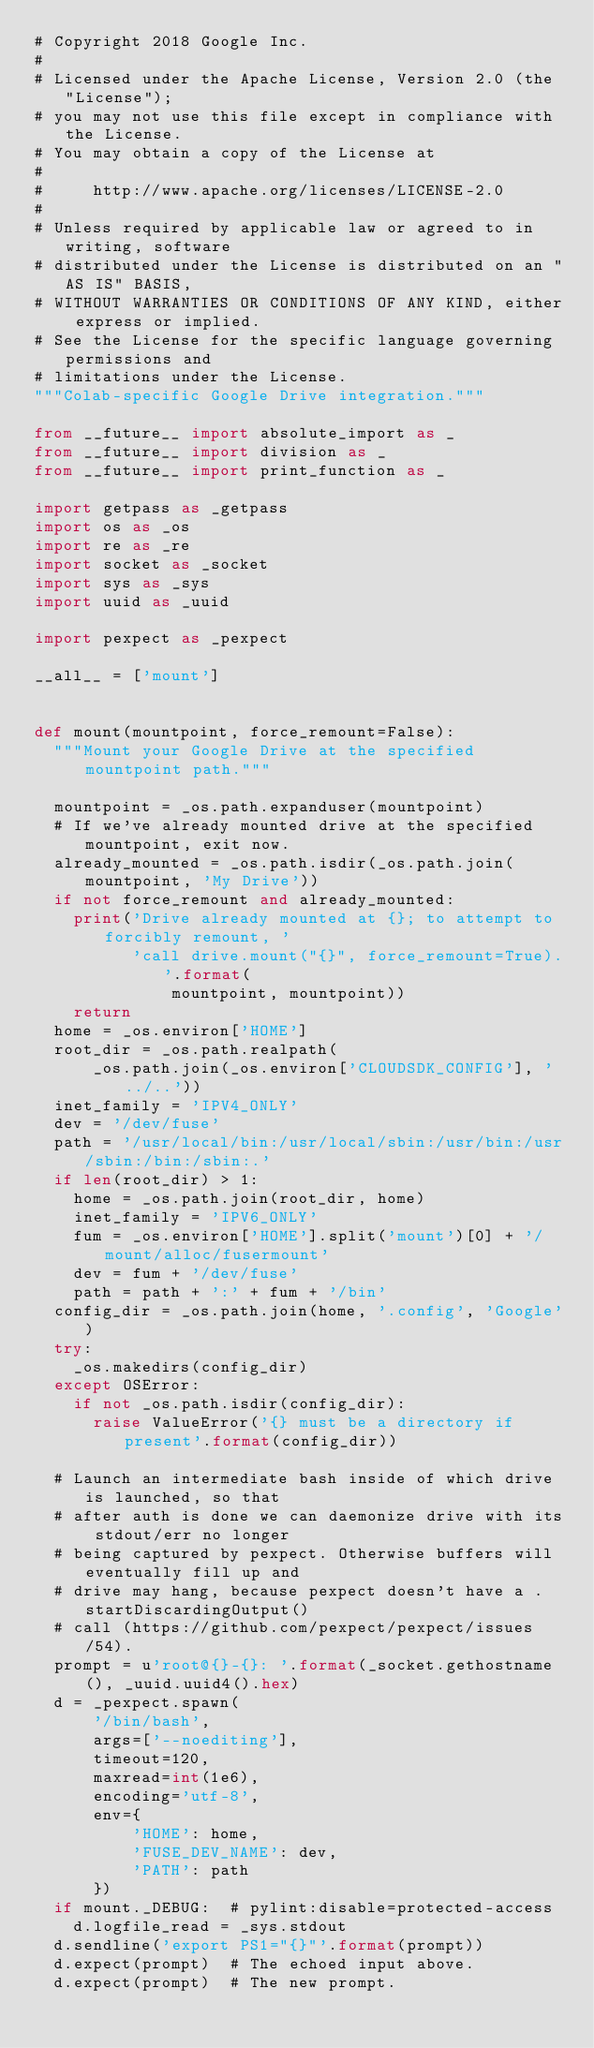<code> <loc_0><loc_0><loc_500><loc_500><_Python_># Copyright 2018 Google Inc.
#
# Licensed under the Apache License, Version 2.0 (the "License");
# you may not use this file except in compliance with the License.
# You may obtain a copy of the License at
#
#     http://www.apache.org/licenses/LICENSE-2.0
#
# Unless required by applicable law or agreed to in writing, software
# distributed under the License is distributed on an "AS IS" BASIS,
# WITHOUT WARRANTIES OR CONDITIONS OF ANY KIND, either express or implied.
# See the License for the specific language governing permissions and
# limitations under the License.
"""Colab-specific Google Drive integration."""

from __future__ import absolute_import as _
from __future__ import division as _
from __future__ import print_function as _

import getpass as _getpass
import os as _os
import re as _re
import socket as _socket
import sys as _sys
import uuid as _uuid

import pexpect as _pexpect

__all__ = ['mount']


def mount(mountpoint, force_remount=False):
  """Mount your Google Drive at the specified mountpoint path."""

  mountpoint = _os.path.expanduser(mountpoint)
  # If we've already mounted drive at the specified mountpoint, exit now.
  already_mounted = _os.path.isdir(_os.path.join(mountpoint, 'My Drive'))
  if not force_remount and already_mounted:
    print('Drive already mounted at {}; to attempt to forcibly remount, '
          'call drive.mount("{}", force_remount=True).'.format(
              mountpoint, mountpoint))
    return
  home = _os.environ['HOME']
  root_dir = _os.path.realpath(
      _os.path.join(_os.environ['CLOUDSDK_CONFIG'], '../..'))
  inet_family = 'IPV4_ONLY'
  dev = '/dev/fuse'
  path = '/usr/local/bin:/usr/local/sbin:/usr/bin:/usr/sbin:/bin:/sbin:.'
  if len(root_dir) > 1:
    home = _os.path.join(root_dir, home)
    inet_family = 'IPV6_ONLY'
    fum = _os.environ['HOME'].split('mount')[0] + '/mount/alloc/fusermount'
    dev = fum + '/dev/fuse'
    path = path + ':' + fum + '/bin'
  config_dir = _os.path.join(home, '.config', 'Google')
  try:
    _os.makedirs(config_dir)
  except OSError:
    if not _os.path.isdir(config_dir):
      raise ValueError('{} must be a directory if present'.format(config_dir))

  # Launch an intermediate bash inside of which drive is launched, so that
  # after auth is done we can daemonize drive with its stdout/err no longer
  # being captured by pexpect. Otherwise buffers will eventually fill up and
  # drive may hang, because pexpect doesn't have a .startDiscardingOutput()
  # call (https://github.com/pexpect/pexpect/issues/54).
  prompt = u'root@{}-{}: '.format(_socket.gethostname(), _uuid.uuid4().hex)
  d = _pexpect.spawn(
      '/bin/bash',
      args=['--noediting'],
      timeout=120,
      maxread=int(1e6),
      encoding='utf-8',
      env={
          'HOME': home,
          'FUSE_DEV_NAME': dev,
          'PATH': path
      })
  if mount._DEBUG:  # pylint:disable=protected-access
    d.logfile_read = _sys.stdout
  d.sendline('export PS1="{}"'.format(prompt))
  d.expect(prompt)  # The echoed input above.
  d.expect(prompt)  # The new prompt.</code> 